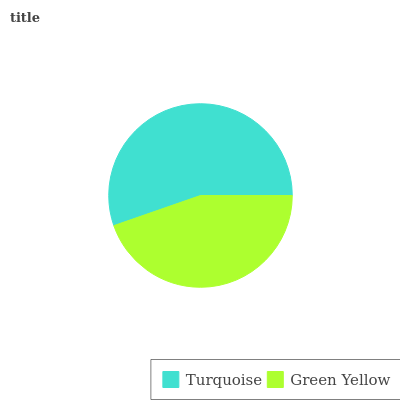Is Green Yellow the minimum?
Answer yes or no. Yes. Is Turquoise the maximum?
Answer yes or no. Yes. Is Green Yellow the maximum?
Answer yes or no. No. Is Turquoise greater than Green Yellow?
Answer yes or no. Yes. Is Green Yellow less than Turquoise?
Answer yes or no. Yes. Is Green Yellow greater than Turquoise?
Answer yes or no. No. Is Turquoise less than Green Yellow?
Answer yes or no. No. Is Turquoise the high median?
Answer yes or no. Yes. Is Green Yellow the low median?
Answer yes or no. Yes. Is Green Yellow the high median?
Answer yes or no. No. Is Turquoise the low median?
Answer yes or no. No. 